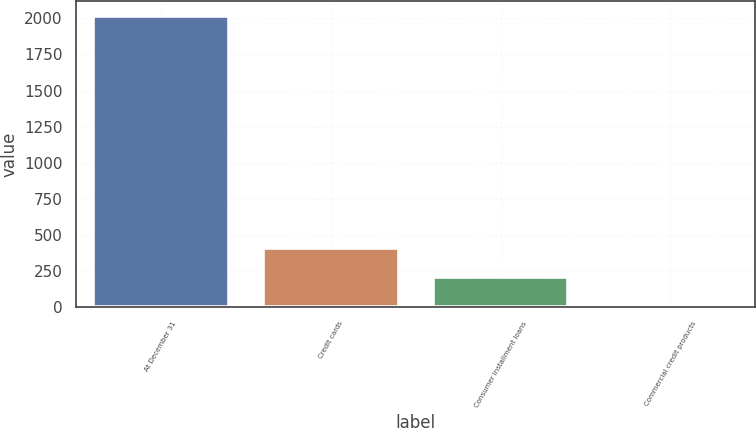Convert chart. <chart><loc_0><loc_0><loc_500><loc_500><bar_chart><fcel>At December 31<fcel>Credit cards<fcel>Consumer installment loans<fcel>Commercial credit products<nl><fcel>2018<fcel>407.6<fcel>206.3<fcel>5<nl></chart> 